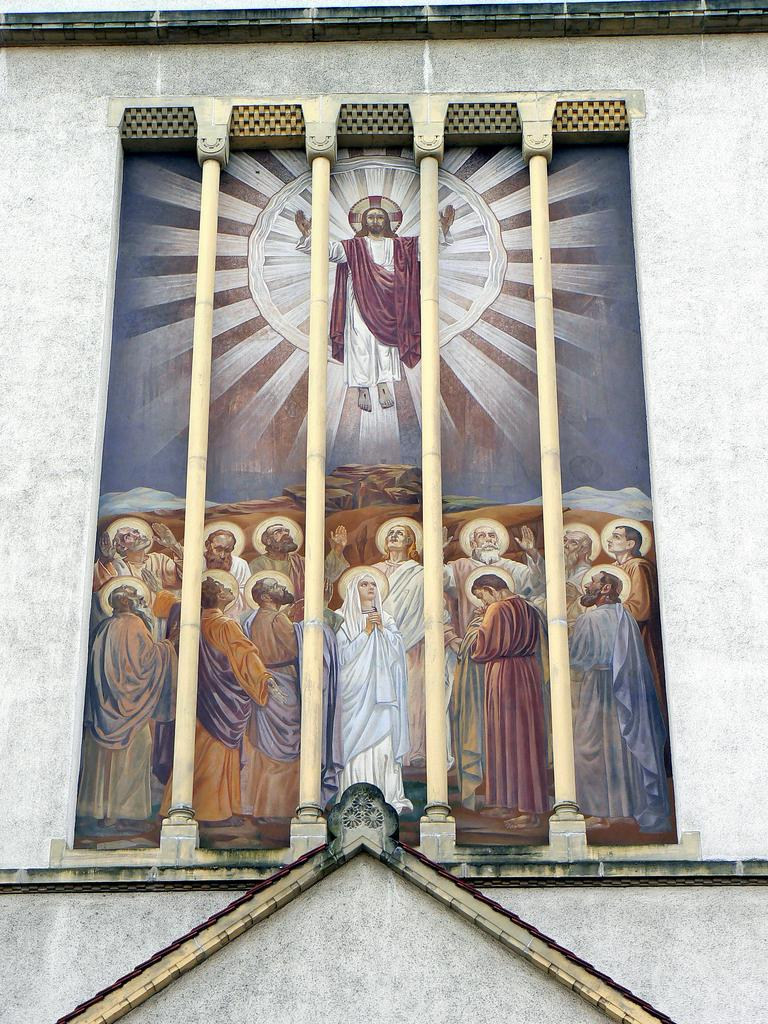What is depicted in the painting on the wall? The painting on the wall depicts Jesus Christ and his disciples. What architectural elements can be seen on the wall? There are pillars on the wall. How does the branch contribute to the pollution in the image? There is no branch or pollution present in the image. What degree of difficulty is required to understand the painting in the image? The image does not convey a degree of difficulty, as it is a static painting of Jesus Christ and his disciples. 